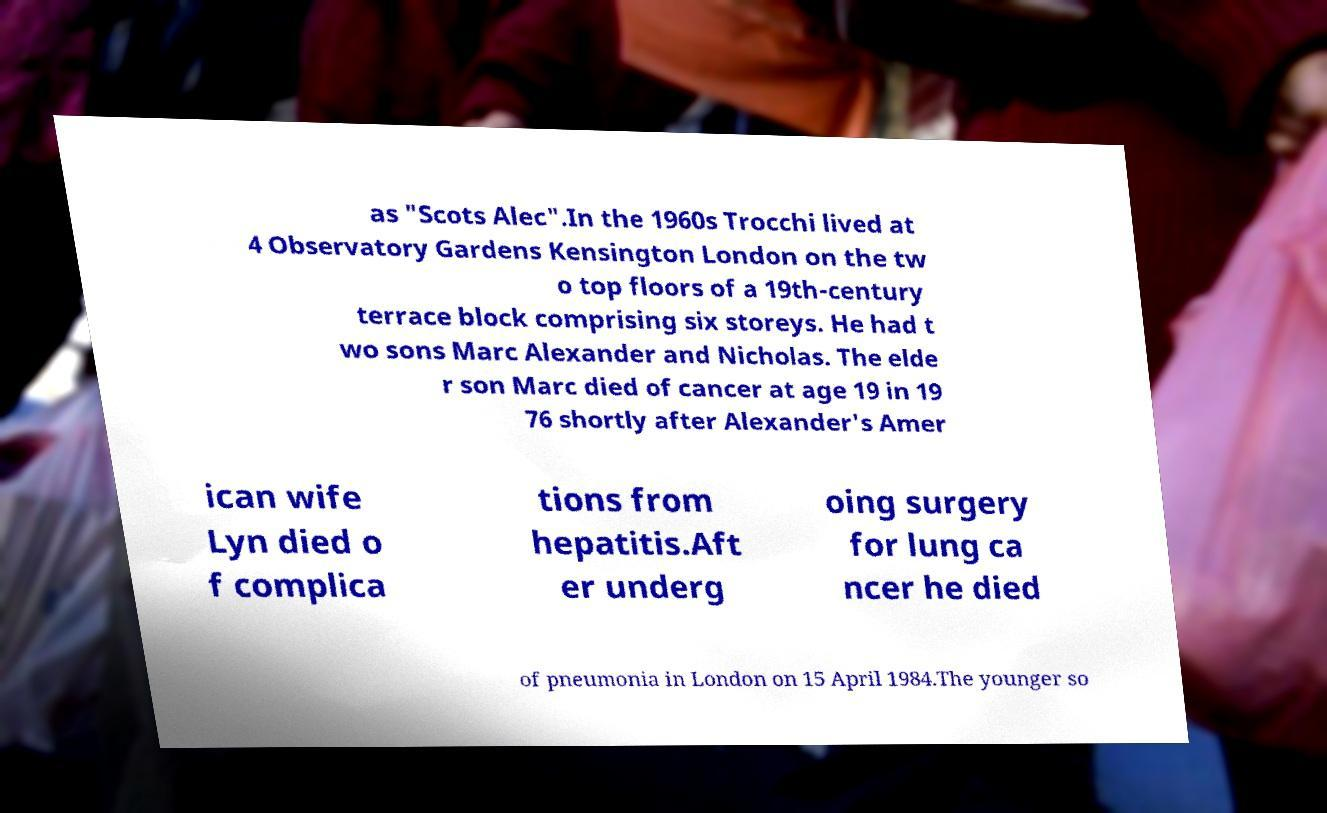Can you accurately transcribe the text from the provided image for me? as "Scots Alec".In the 1960s Trocchi lived at 4 Observatory Gardens Kensington London on the tw o top floors of a 19th-century terrace block comprising six storeys. He had t wo sons Marc Alexander and Nicholas. The elde r son Marc died of cancer at age 19 in 19 76 shortly after Alexander's Amer ican wife Lyn died o f complica tions from hepatitis.Aft er underg oing surgery for lung ca ncer he died of pneumonia in London on 15 April 1984.The younger so 